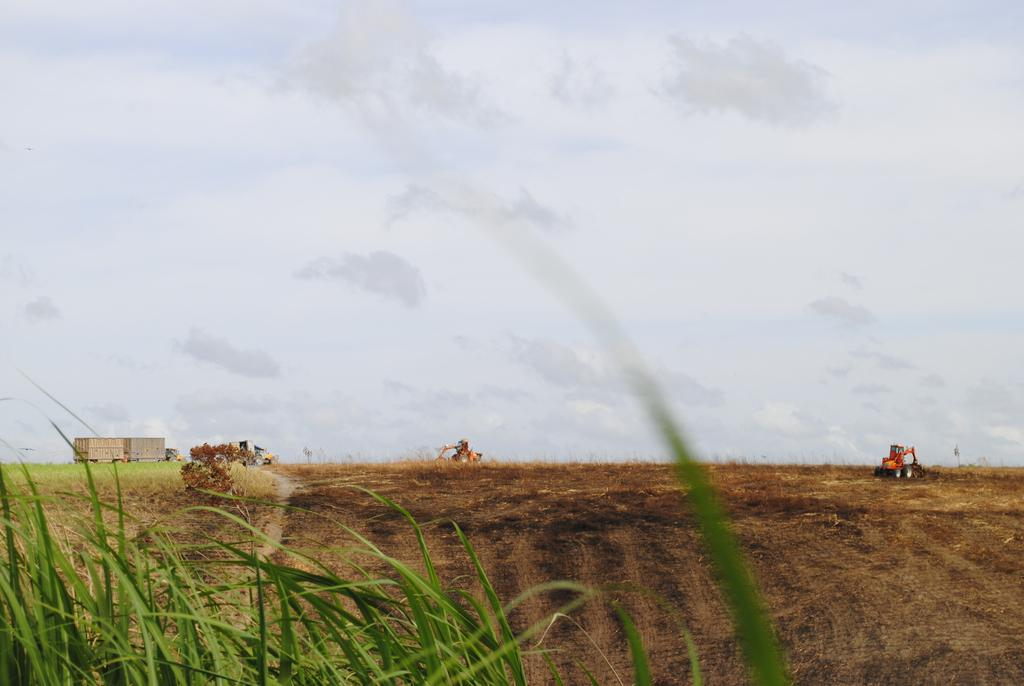What type of landscape is depicted in the image? There is a field in the image. What else can be seen in the field? Grass is present in the field. What is the other main subject in the image? There is a vehicle in the image. What can be seen in the background of the image? The sky is visible in the image. What type of eggnog can be seen in the field in the image? There is no eggnog present in the image; it features a field and a vehicle. Can you tell me how many ants are crawling on the vehicle in the image? There are no ants visible on the vehicle in the image. 